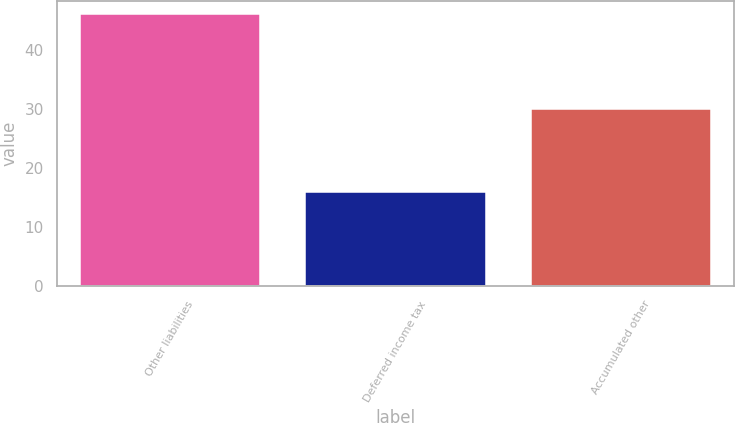<chart> <loc_0><loc_0><loc_500><loc_500><bar_chart><fcel>Other liabilities<fcel>Deferred income tax<fcel>Accumulated other<nl><fcel>46<fcel>16<fcel>30<nl></chart> 